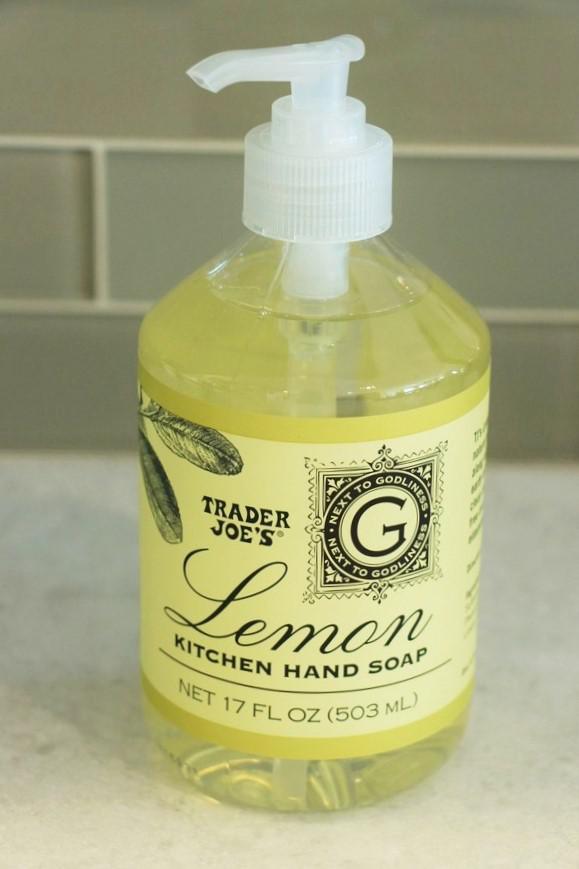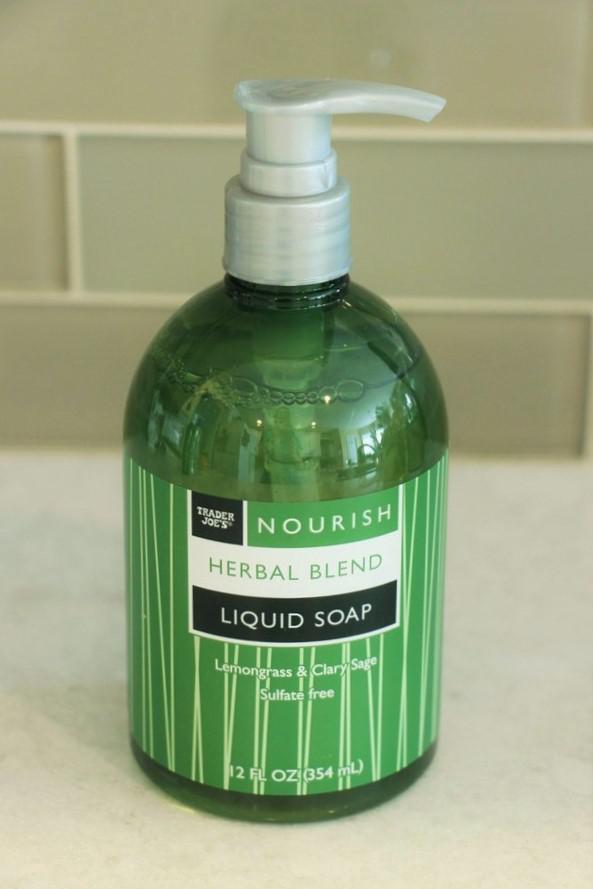The first image is the image on the left, the second image is the image on the right. Evaluate the accuracy of this statement regarding the images: "There is at least one spray bottle that contains multi purpose cleaner.". Is it true? Answer yes or no. No. 